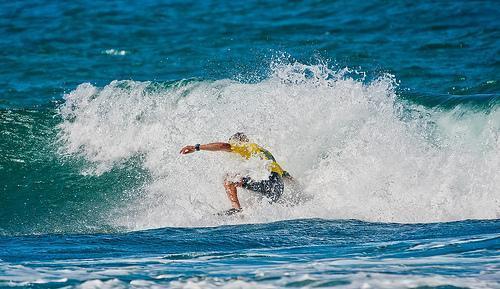How many people are shown?
Give a very brief answer. 1. 